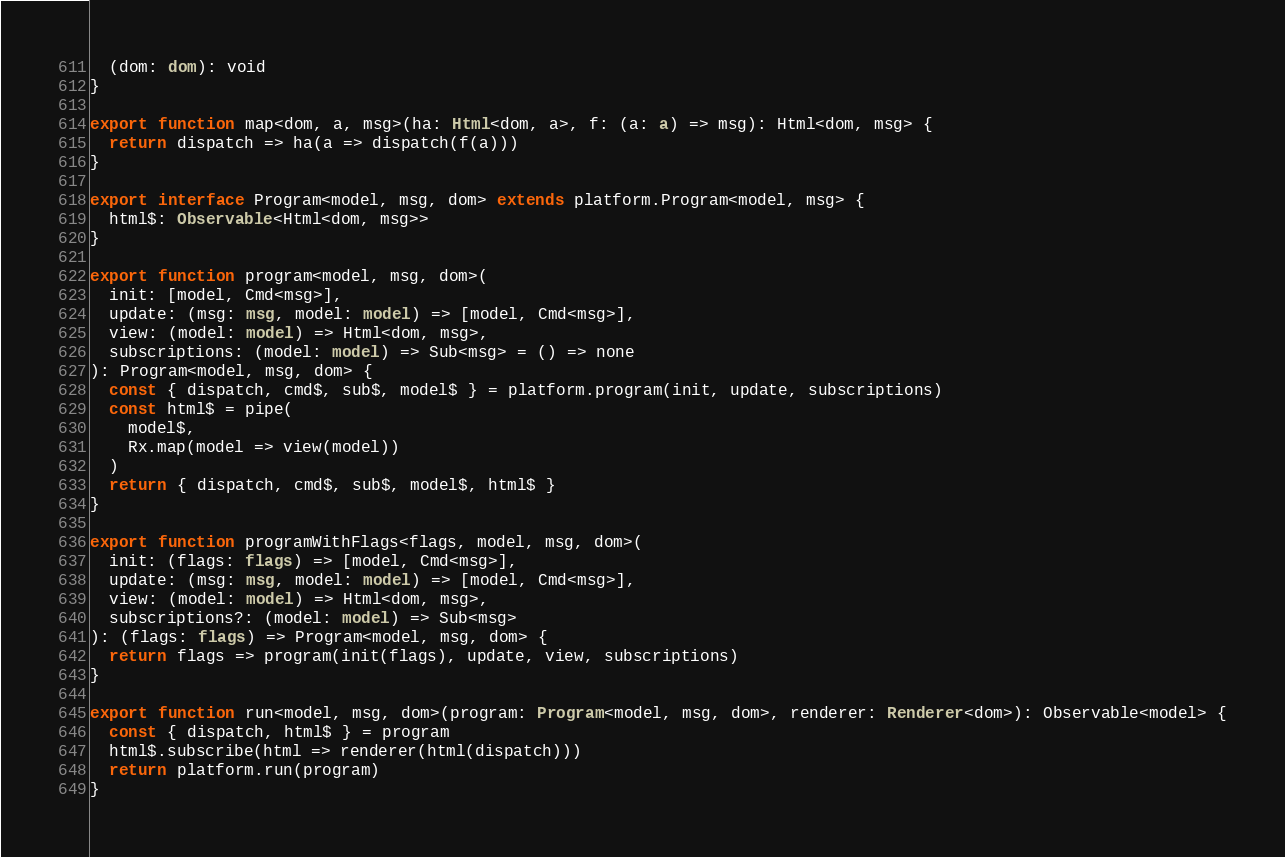<code> <loc_0><loc_0><loc_500><loc_500><_TypeScript_>  (dom: dom): void
}

export function map<dom, a, msg>(ha: Html<dom, a>, f: (a: a) => msg): Html<dom, msg> {
  return dispatch => ha(a => dispatch(f(a)))
}

export interface Program<model, msg, dom> extends platform.Program<model, msg> {
  html$: Observable<Html<dom, msg>>
}

export function program<model, msg, dom>(
  init: [model, Cmd<msg>],
  update: (msg: msg, model: model) => [model, Cmd<msg>],
  view: (model: model) => Html<dom, msg>,
  subscriptions: (model: model) => Sub<msg> = () => none
): Program<model, msg, dom> {
  const { dispatch, cmd$, sub$, model$ } = platform.program(init, update, subscriptions)
  const html$ = pipe(
    model$,
    Rx.map(model => view(model))
  )
  return { dispatch, cmd$, sub$, model$, html$ }
}

export function programWithFlags<flags, model, msg, dom>(
  init: (flags: flags) => [model, Cmd<msg>],
  update: (msg: msg, model: model) => [model, Cmd<msg>],
  view: (model: model) => Html<dom, msg>,
  subscriptions?: (model: model) => Sub<msg>
): (flags: flags) => Program<model, msg, dom> {
  return flags => program(init(flags), update, view, subscriptions)
}

export function run<model, msg, dom>(program: Program<model, msg, dom>, renderer: Renderer<dom>): Observable<model> {
  const { dispatch, html$ } = program
  html$.subscribe(html => renderer(html(dispatch)))
  return platform.run(program)
}
</code> 